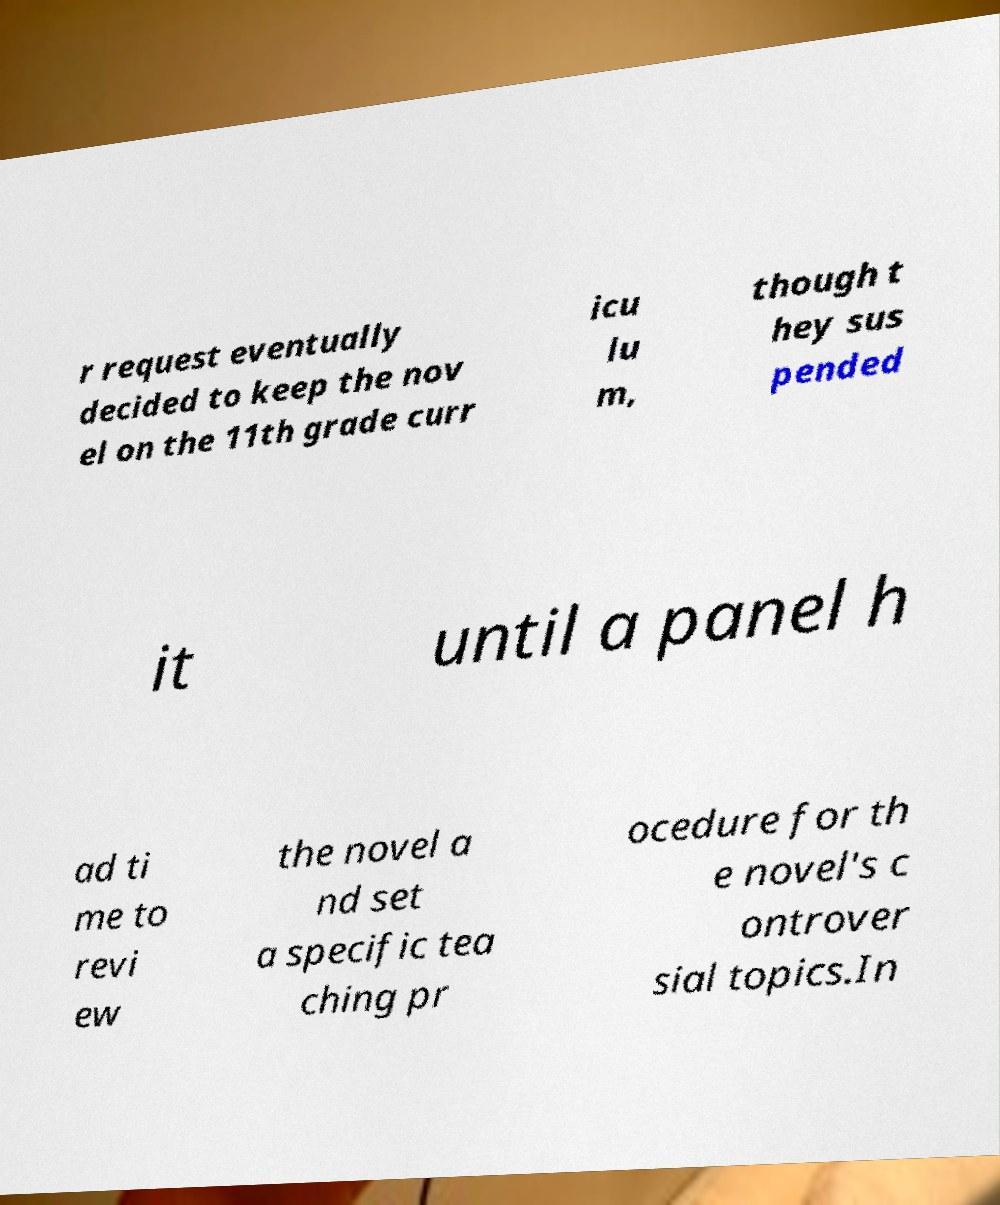Please read and relay the text visible in this image. What does it say? r request eventually decided to keep the nov el on the 11th grade curr icu lu m, though t hey sus pended it until a panel h ad ti me to revi ew the novel a nd set a specific tea ching pr ocedure for th e novel's c ontrover sial topics.In 